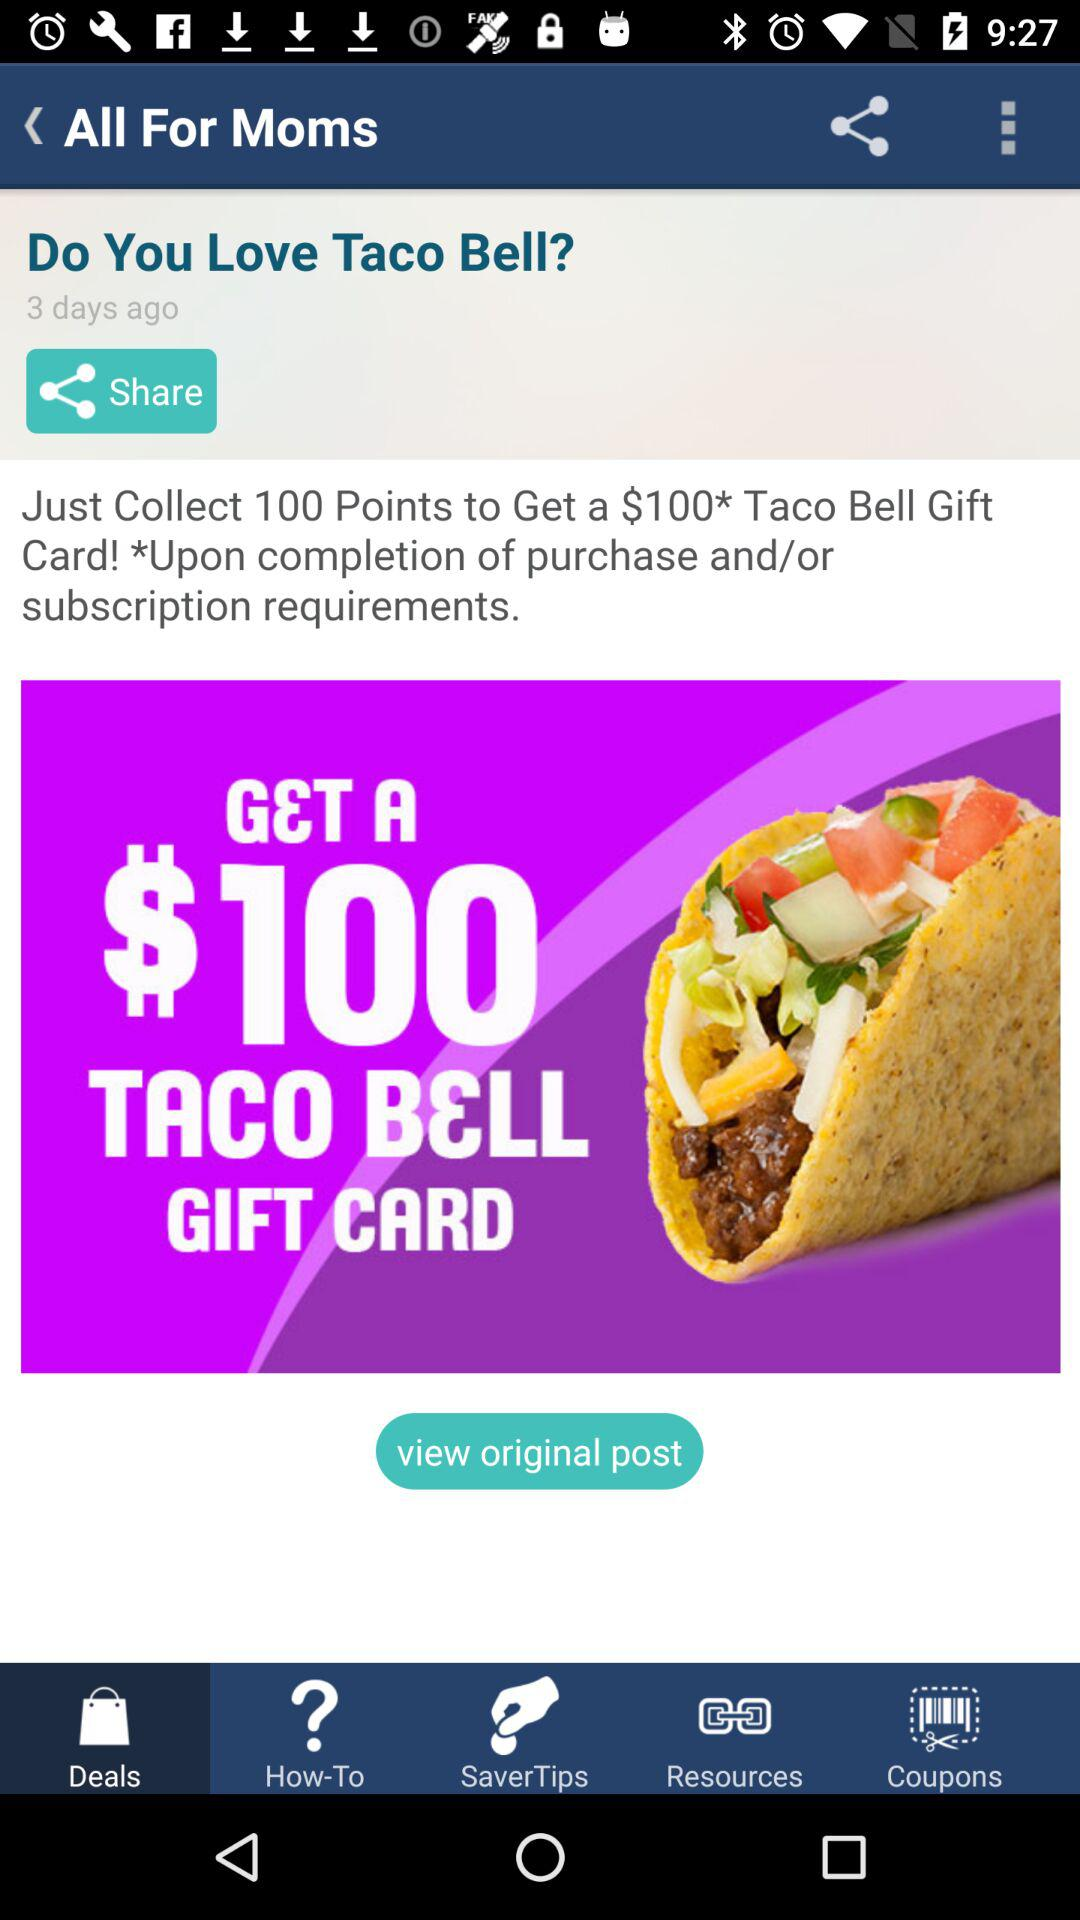How many dollars can we get after collecting the 100 points? You can get $100 after collecting the 100 points. 